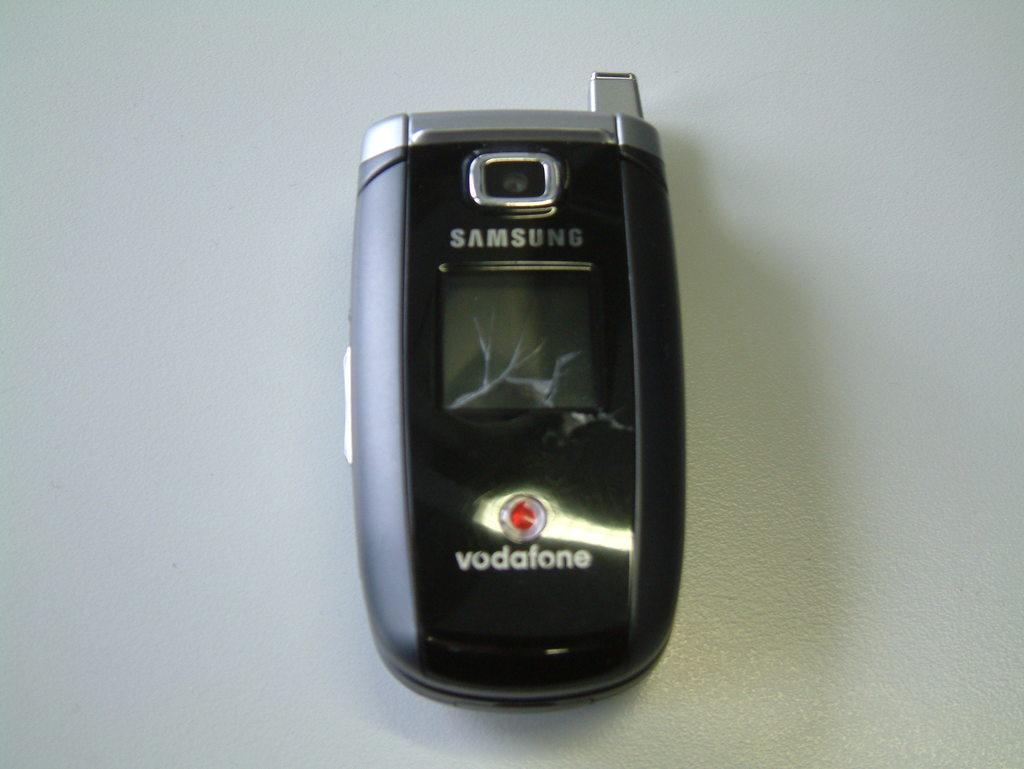Provide a one-sentence caption for the provided image. A black vodaphone by Samsung sits on a flat surface. 